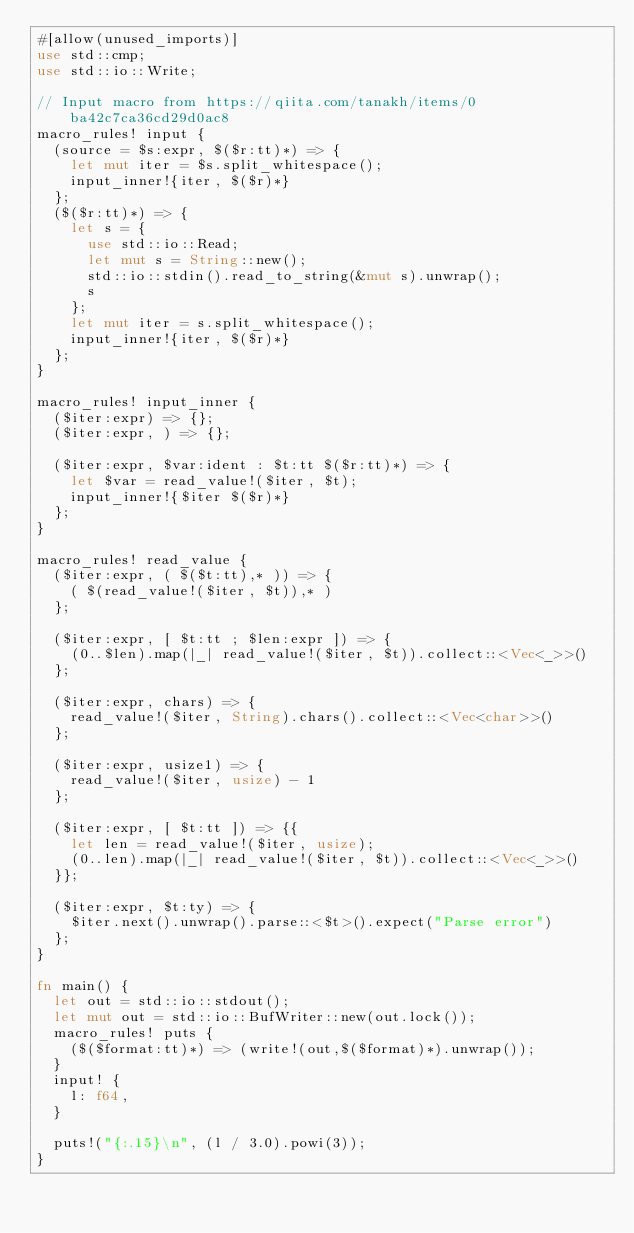<code> <loc_0><loc_0><loc_500><loc_500><_Rust_>#[allow(unused_imports)]
use std::cmp;
use std::io::Write;

// Input macro from https://qiita.com/tanakh/items/0ba42c7ca36cd29d0ac8
macro_rules! input {
  (source = $s:expr, $($r:tt)*) => {
    let mut iter = $s.split_whitespace();
    input_inner!{iter, $($r)*}
  };
  ($($r:tt)*) => {
    let s = {
      use std::io::Read;
      let mut s = String::new();
      std::io::stdin().read_to_string(&mut s).unwrap();
      s
    };
    let mut iter = s.split_whitespace();
    input_inner!{iter, $($r)*}
  };
}

macro_rules! input_inner {
  ($iter:expr) => {};
  ($iter:expr, ) => {};

  ($iter:expr, $var:ident : $t:tt $($r:tt)*) => {
    let $var = read_value!($iter, $t);
    input_inner!{$iter $($r)*}
  };
}

macro_rules! read_value {
  ($iter:expr, ( $($t:tt),* )) => {
    ( $(read_value!($iter, $t)),* )
  };

  ($iter:expr, [ $t:tt ; $len:expr ]) => {
    (0..$len).map(|_| read_value!($iter, $t)).collect::<Vec<_>>()
  };

  ($iter:expr, chars) => {
    read_value!($iter, String).chars().collect::<Vec<char>>()
  };

  ($iter:expr, usize1) => {
    read_value!($iter, usize) - 1
  };

  ($iter:expr, [ $t:tt ]) => {{
    let len = read_value!($iter, usize);
    (0..len).map(|_| read_value!($iter, $t)).collect::<Vec<_>>()
  }};

  ($iter:expr, $t:ty) => {
    $iter.next().unwrap().parse::<$t>().expect("Parse error")
  };
}

fn main() {
  let out = std::io::stdout();
  let mut out = std::io::BufWriter::new(out.lock());
  macro_rules! puts {
    ($($format:tt)*) => (write!(out,$($format)*).unwrap());
  }
  input! {
    l: f64,
  }

  puts!("{:.15}\n", (l / 3.0).powi(3));
}
</code> 